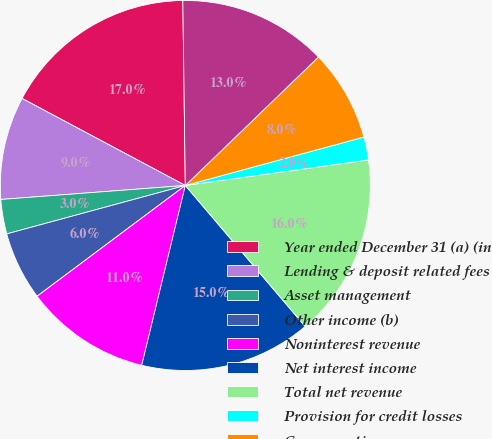Convert chart. <chart><loc_0><loc_0><loc_500><loc_500><pie_chart><fcel>Year ended December 31 (a) (in<fcel>Lending & deposit related fees<fcel>Asset management<fcel>Other income (b)<fcel>Noninterest revenue<fcel>Net interest income<fcel>Total net revenue<fcel>Provision for credit losses<fcel>Compensation expense<fcel>Noncompensation expense<nl><fcel>16.99%<fcel>9.0%<fcel>3.01%<fcel>6.0%<fcel>11.0%<fcel>15.0%<fcel>15.99%<fcel>2.01%<fcel>8.0%<fcel>13.0%<nl></chart> 